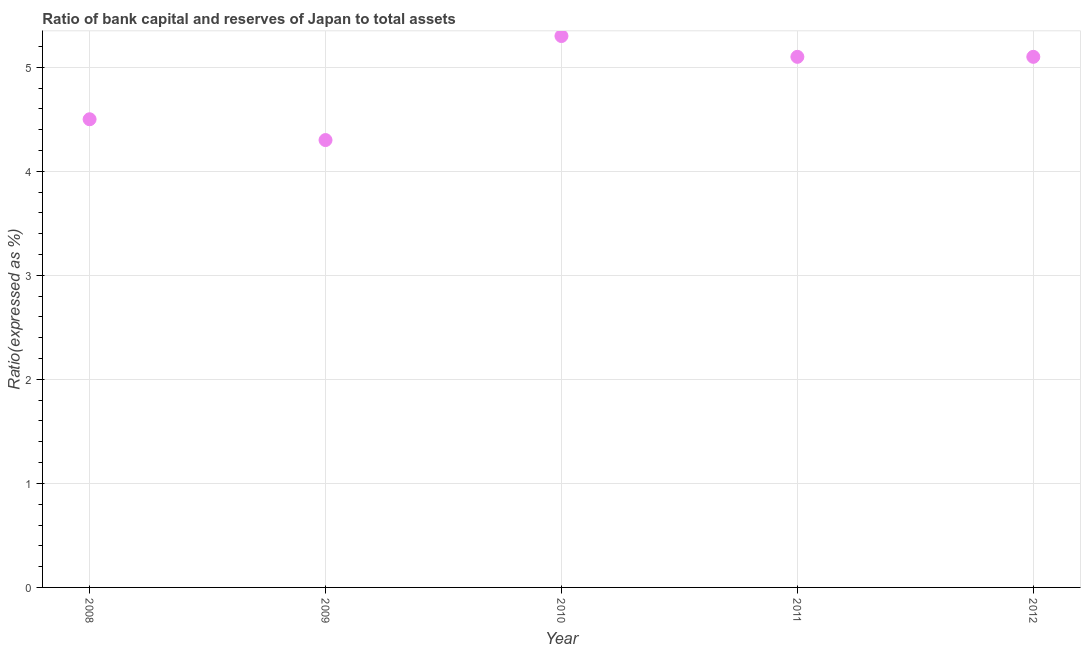In which year was the bank capital to assets ratio minimum?
Your answer should be compact. 2009. What is the sum of the bank capital to assets ratio?
Provide a succinct answer. 24.3. What is the difference between the bank capital to assets ratio in 2009 and 2011?
Make the answer very short. -0.8. What is the average bank capital to assets ratio per year?
Your answer should be compact. 4.86. Do a majority of the years between 2009 and 2010 (inclusive) have bank capital to assets ratio greater than 3 %?
Your response must be concise. Yes. What is the ratio of the bank capital to assets ratio in 2008 to that in 2009?
Ensure brevity in your answer.  1.05. What is the difference between the highest and the second highest bank capital to assets ratio?
Make the answer very short. 0.2. What is the difference between the highest and the lowest bank capital to assets ratio?
Make the answer very short. 1. How many dotlines are there?
Provide a succinct answer. 1. How many years are there in the graph?
Provide a succinct answer. 5. Are the values on the major ticks of Y-axis written in scientific E-notation?
Your answer should be very brief. No. Does the graph contain any zero values?
Make the answer very short. No. Does the graph contain grids?
Offer a very short reply. Yes. What is the title of the graph?
Your answer should be very brief. Ratio of bank capital and reserves of Japan to total assets. What is the label or title of the X-axis?
Keep it short and to the point. Year. What is the label or title of the Y-axis?
Offer a very short reply. Ratio(expressed as %). What is the Ratio(expressed as %) in 2008?
Your answer should be compact. 4.5. What is the Ratio(expressed as %) in 2010?
Provide a succinct answer. 5.3. What is the difference between the Ratio(expressed as %) in 2008 and 2009?
Ensure brevity in your answer.  0.2. What is the difference between the Ratio(expressed as %) in 2008 and 2010?
Provide a succinct answer. -0.8. What is the difference between the Ratio(expressed as %) in 2008 and 2011?
Make the answer very short. -0.6. What is the difference between the Ratio(expressed as %) in 2008 and 2012?
Your answer should be very brief. -0.6. What is the difference between the Ratio(expressed as %) in 2009 and 2010?
Offer a very short reply. -1. What is the difference between the Ratio(expressed as %) in 2009 and 2011?
Ensure brevity in your answer.  -0.8. What is the difference between the Ratio(expressed as %) in 2009 and 2012?
Your answer should be compact. -0.8. What is the difference between the Ratio(expressed as %) in 2010 and 2011?
Give a very brief answer. 0.2. What is the difference between the Ratio(expressed as %) in 2011 and 2012?
Ensure brevity in your answer.  0. What is the ratio of the Ratio(expressed as %) in 2008 to that in 2009?
Provide a short and direct response. 1.05. What is the ratio of the Ratio(expressed as %) in 2008 to that in 2010?
Offer a very short reply. 0.85. What is the ratio of the Ratio(expressed as %) in 2008 to that in 2011?
Offer a very short reply. 0.88. What is the ratio of the Ratio(expressed as %) in 2008 to that in 2012?
Ensure brevity in your answer.  0.88. What is the ratio of the Ratio(expressed as %) in 2009 to that in 2010?
Your answer should be very brief. 0.81. What is the ratio of the Ratio(expressed as %) in 2009 to that in 2011?
Give a very brief answer. 0.84. What is the ratio of the Ratio(expressed as %) in 2009 to that in 2012?
Provide a succinct answer. 0.84. What is the ratio of the Ratio(expressed as %) in 2010 to that in 2011?
Keep it short and to the point. 1.04. What is the ratio of the Ratio(expressed as %) in 2010 to that in 2012?
Provide a succinct answer. 1.04. What is the ratio of the Ratio(expressed as %) in 2011 to that in 2012?
Your answer should be very brief. 1. 